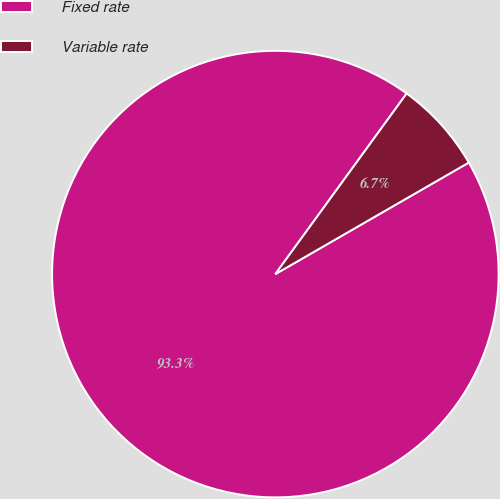Convert chart to OTSL. <chart><loc_0><loc_0><loc_500><loc_500><pie_chart><fcel>Fixed rate<fcel>Variable rate<nl><fcel>93.33%<fcel>6.67%<nl></chart> 